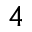<formula> <loc_0><loc_0><loc_500><loc_500>^ { 4 }</formula> 